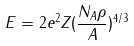<formula> <loc_0><loc_0><loc_500><loc_500>E = 2 e ^ { 2 } Z ( \frac { N _ { A } \rho } { A } ) ^ { 4 / 3 }</formula> 